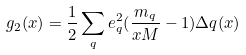Convert formula to latex. <formula><loc_0><loc_0><loc_500><loc_500>g _ { 2 } ( x ) = \frac { 1 } { 2 } \sum _ { q } e ^ { 2 } _ { q } ( \frac { m _ { q } } { x M } - 1 ) \Delta q ( x )</formula> 